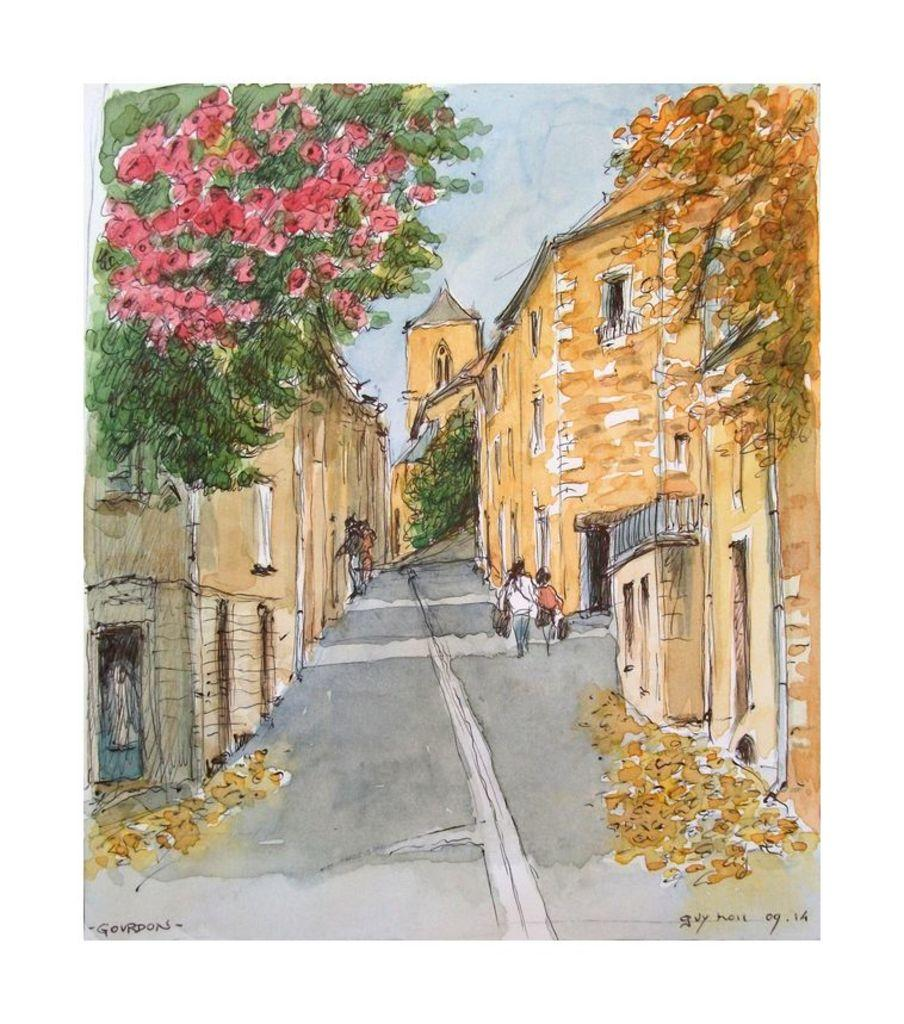What is the main subject of the image? The image contains a painting. What is happening in the painting? The painting depicts a group of people standing. What type of structures are included in the painting? The painting includes buildings with windows. What natural elements are featured in the painting? The painting features flowers and trees. What can be seen in the sky in the painting? The sky is visible in the painting. What type of lunch is being served to the donkey in the painting? There is no donkey or lunch present in the painting; it features a group of people, buildings, flowers, trees, and a visible sky. 